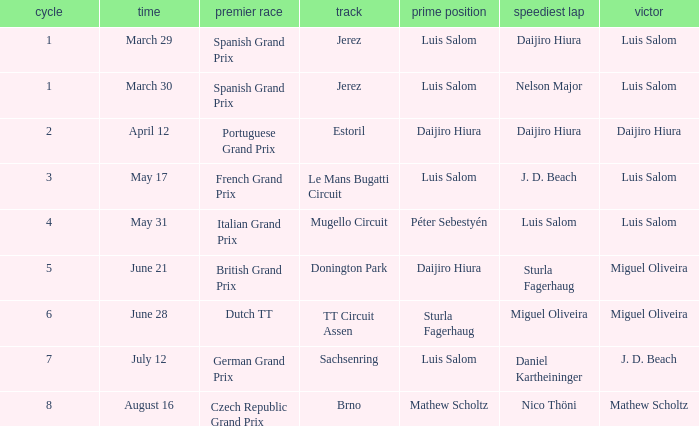Who had the fastest lap in the Dutch TT Grand Prix?  Miguel Oliveira. 